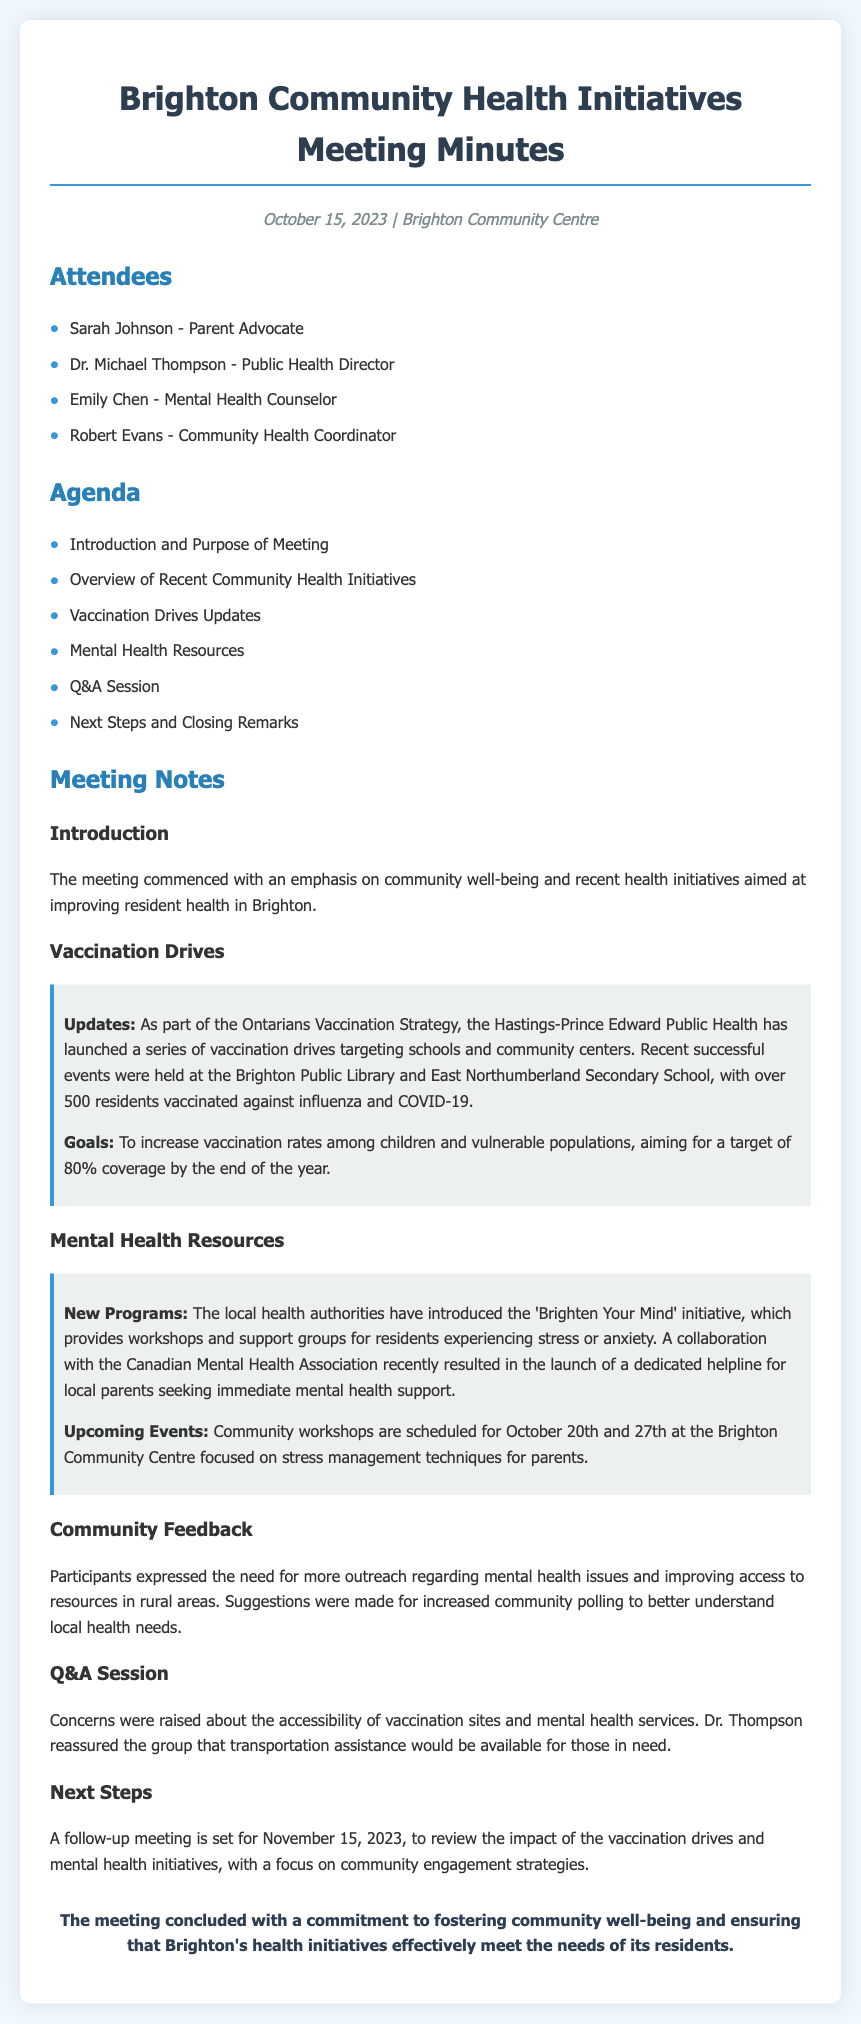what was the date of the meeting? The meeting was held on October 15, 2023, as stated in the document.
Answer: October 15, 2023 who is the Public Health Director? The document states that Dr. Michael Thompson is the Public Health Director.
Answer: Dr. Michael Thompson how many residents were vaccinated in recent events? The document mentions that over 500 residents were vaccinated against influenza and COVID-19.
Answer: over 500 what is the target vaccination coverage by the end of the year? The document indicates that the goal is to achieve an 80% vaccination coverage among children and vulnerable populations.
Answer: 80% when are the upcoming community workshops scheduled? The document specifies that community workshops are scheduled for October 20th and 27th.
Answer: October 20th and 27th what initiative provides support for residents experiencing stress or anxiety? The document mentions the 'Brighten Your Mind' initiative as a program that provides such support.
Answer: 'Brighten Your Mind' what did participants express a need for regarding mental health? According to the document, participants expressed the need for more outreach regarding mental health issues.
Answer: more outreach what is the purpose of the follow-up meeting on November 15, 2023? The document states that the follow-up meeting aims to review the impact of vaccination drives and mental health initiatives.
Answer: review the impact how many attendees were listed in total? The document lists four attendees in the meeting notes.
Answer: four 